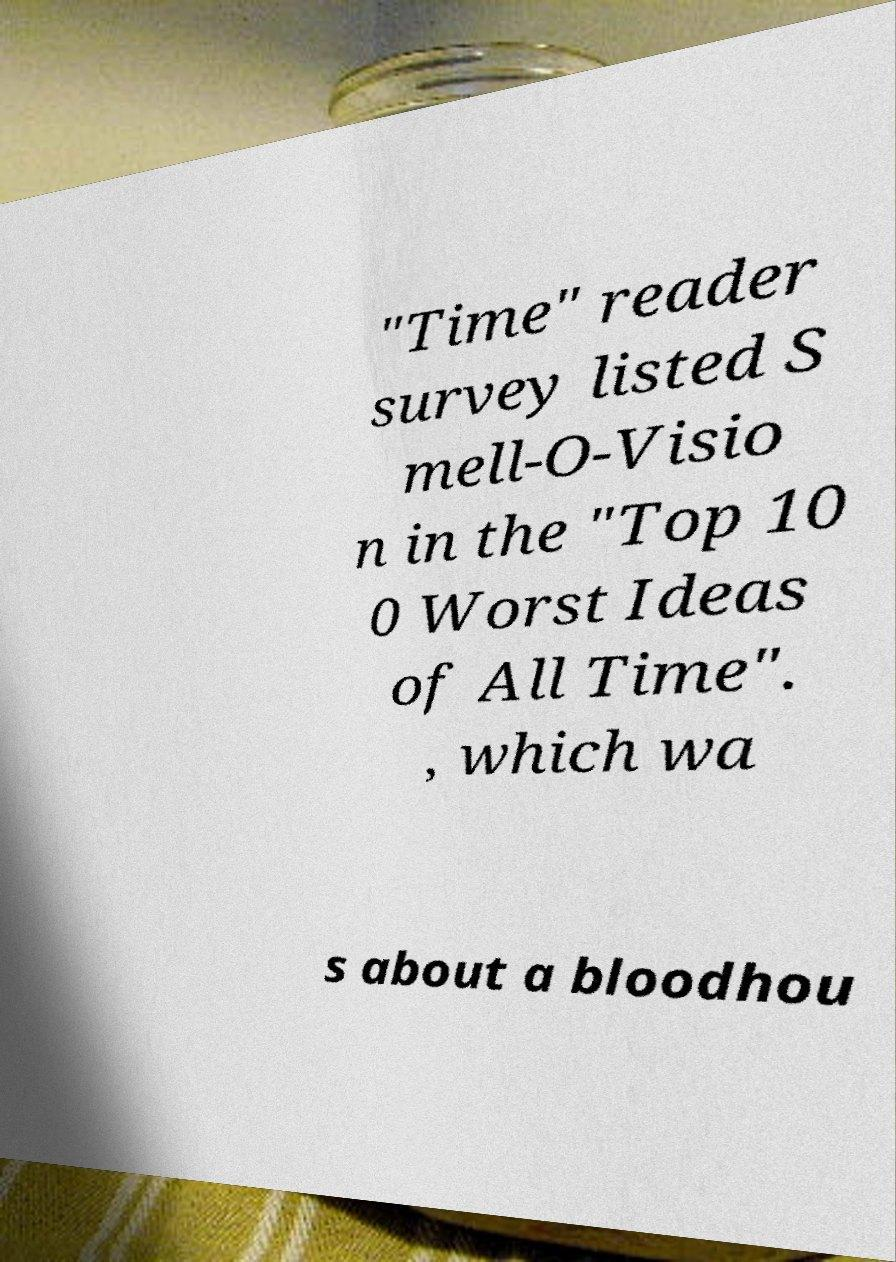Could you extract and type out the text from this image? "Time" reader survey listed S mell-O-Visio n in the "Top 10 0 Worst Ideas of All Time". , which wa s about a bloodhou 